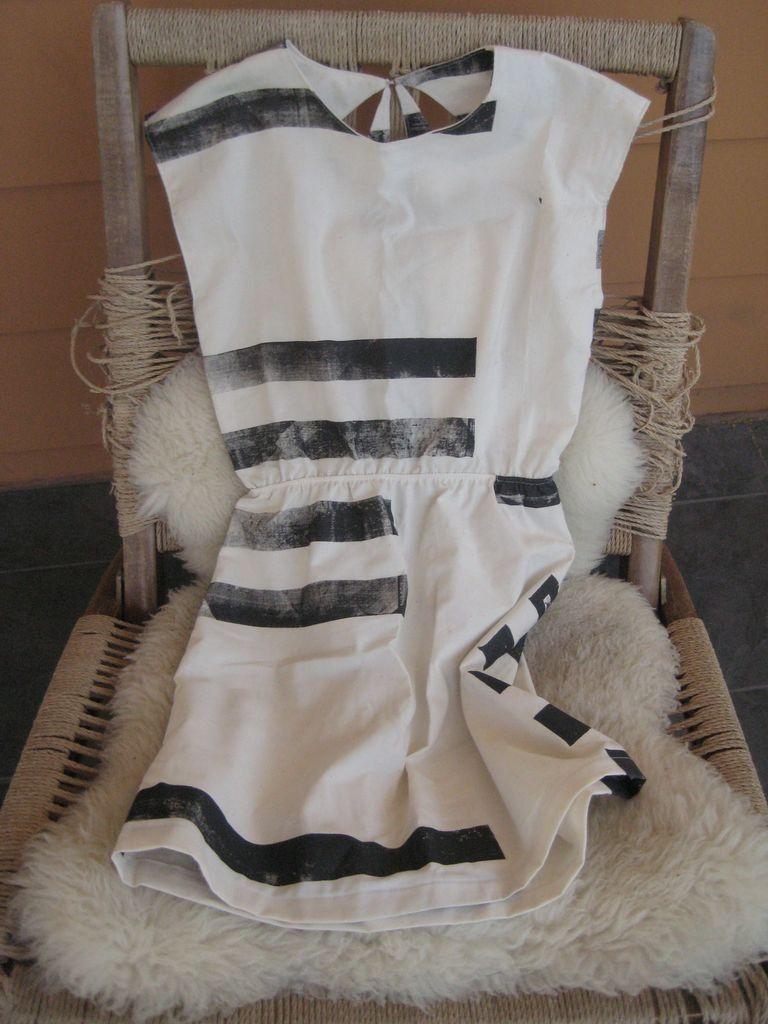In one or two sentences, can you explain what this image depicts? In this image there is one chair as we can see in middle of this image and there is one cloth kept on this chair that is in white color,and there is a wall in the background. 